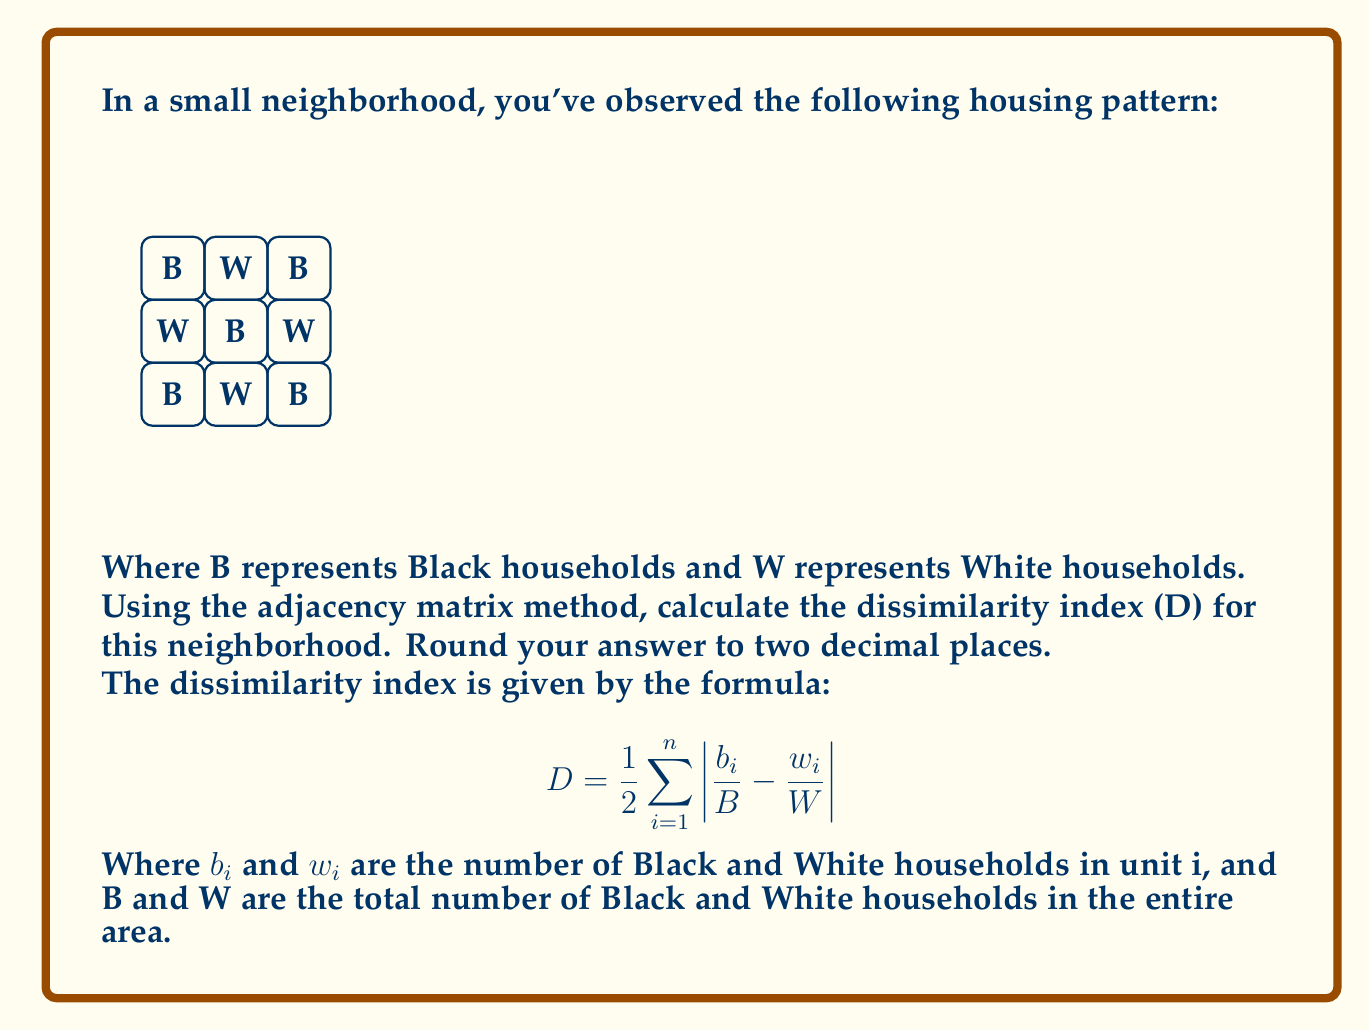Solve this math problem. Let's approach this step-by-step:

1) First, we need to create the adjacency matrix. Each cell is adjacent to its neighboring cells (including diagonals). The matrix will be 9x9 (for 9 cells):

$$
A = \begin{bmatrix}
0 & 1 & 0 & 1 & 1 & 0 & 0 & 0 & 0 \\
1 & 0 & 1 & 1 & 1 & 1 & 0 & 0 & 0 \\
0 & 1 & 0 & 0 & 1 & 1 & 0 & 0 & 0 \\
1 & 1 & 0 & 0 & 1 & 0 & 1 & 1 & 0 \\
1 & 1 & 1 & 1 & 0 & 1 & 1 & 1 & 1 \\
0 & 1 & 1 & 0 & 1 & 0 & 0 & 1 & 1 \\
0 & 0 & 0 & 1 & 1 & 0 & 0 & 1 & 0 \\
0 & 0 & 0 & 1 & 1 & 1 & 1 & 0 & 1 \\
0 & 0 & 0 & 0 & 1 & 1 & 0 & 1 & 0
\end{bmatrix}
$$

2) Now, we need to count the total number of Black (B) and White (W) households:
   B = 5, W = 4

3) For each unit i, we need to calculate $b_i$ and $w_i$:
   - $b_1 = 1$, $w_1 = 3$
   - $b_2 = 2$, $w_2 = 2$
   - $b_3 = 1$, $w_3 = 2$
   - $b_4 = 2$, $w_4 = 2$
   - $b_5 = 3$, $w_5 = 5$
   - $b_6 = 2$, $w_6 = 3$
   - $b_7 = 1$, $w_7 = 2$
   - $b_8 = 2$, $w_8 = 2$
   - $b_9 = 1$, $w_9 = 1$

4) Now we can calculate each term of the sum:

   $|\frac{b_1}{B} - \frac{w_1}{W}| = |\frac{1}{5} - \frac{3}{4}| = 0.55$
   $|\frac{b_2}{B} - \frac{w_2}{W}| = |\frac{2}{5} - \frac{2}{4}| = 0.10$
   $|\frac{b_3}{B} - \frac{w_3}{W}| = |\frac{1}{5} - \frac{2}{4}| = 0.30$
   $|\frac{b_4}{B} - \frac{w_4}{W}| = |\frac{2}{5} - \frac{2}{4}| = 0.10$
   $|\frac{b_5}{B} - \frac{w_5}{W}| = |\frac{3}{5} - \frac{5}{4}| = 0.65$
   $|\frac{b_6}{B} - \frac{w_6}{W}| = |\frac{2}{5} - \frac{3}{4}| = 0.35$
   $|\frac{b_7}{B} - \frac{w_7}{W}| = |\frac{1}{5} - \frac{2}{4}| = 0.30$
   $|\frac{b_8}{B} - \frac{w_8}{W}| = |\frac{2}{5} - \frac{2}{4}| = 0.10$
   $|\frac{b_9}{B} - \frac{w_9}{W}| = |\frac{1}{5} - \frac{1}{4}| = 0.05$

5) Sum these values and multiply by $\frac{1}{2}$:

   $D = \frac{1}{2} (0.55 + 0.10 + 0.30 + 0.10 + 0.65 + 0.35 + 0.30 + 0.10 + 0.05)$
   $D = \frac{1}{2} (2.50) = 1.25$

6) Rounding to two decimal places:
   $D \approx 1.25$
Answer: 1.25 